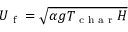<formula> <loc_0><loc_0><loc_500><loc_500>U _ { f } = \sqrt { \alpha g T _ { c h a r } H }</formula> 